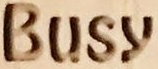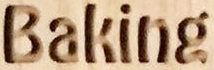What text is displayed in these images sequentially, separated by a semicolon? Busy; Baking 